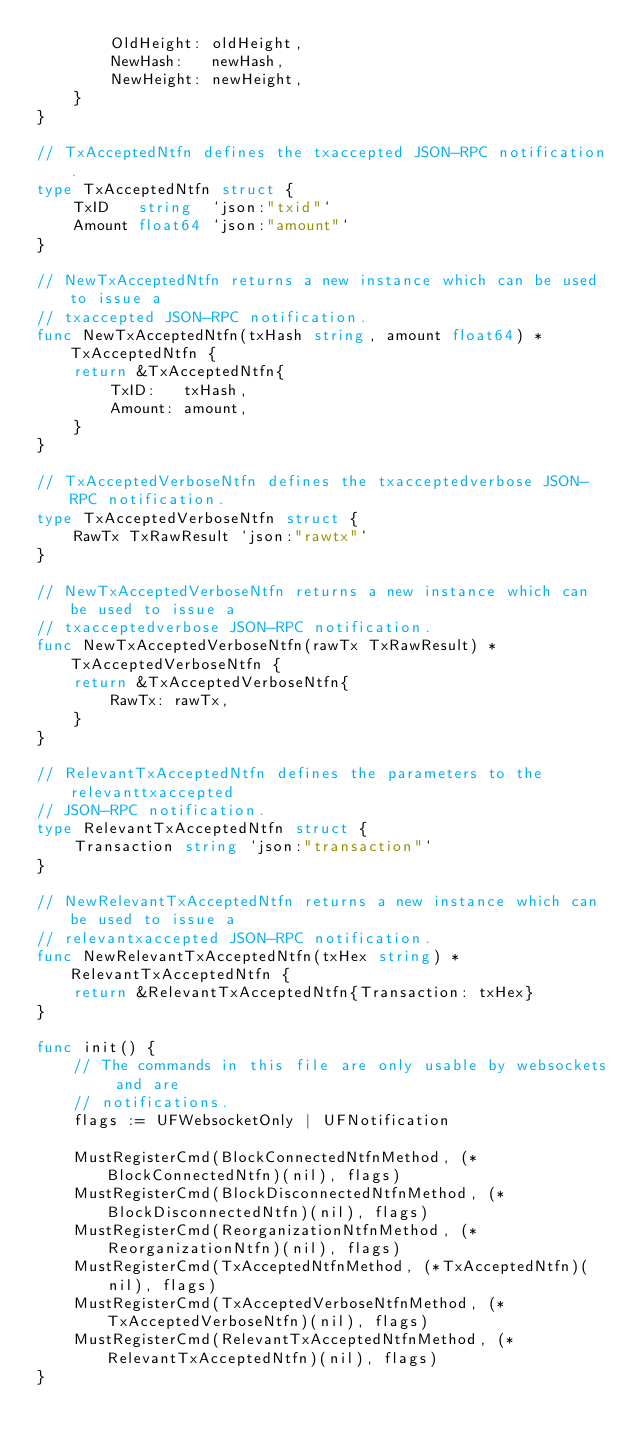<code> <loc_0><loc_0><loc_500><loc_500><_Go_>		OldHeight: oldHeight,
		NewHash:   newHash,
		NewHeight: newHeight,
	}
}

// TxAcceptedNtfn defines the txaccepted JSON-RPC notification.
type TxAcceptedNtfn struct {
	TxID   string  `json:"txid"`
	Amount float64 `json:"amount"`
}

// NewTxAcceptedNtfn returns a new instance which can be used to issue a
// txaccepted JSON-RPC notification.
func NewTxAcceptedNtfn(txHash string, amount float64) *TxAcceptedNtfn {
	return &TxAcceptedNtfn{
		TxID:   txHash,
		Amount: amount,
	}
}

// TxAcceptedVerboseNtfn defines the txacceptedverbose JSON-RPC notification.
type TxAcceptedVerboseNtfn struct {
	RawTx TxRawResult `json:"rawtx"`
}

// NewTxAcceptedVerboseNtfn returns a new instance which can be used to issue a
// txacceptedverbose JSON-RPC notification.
func NewTxAcceptedVerboseNtfn(rawTx TxRawResult) *TxAcceptedVerboseNtfn {
	return &TxAcceptedVerboseNtfn{
		RawTx: rawTx,
	}
}

// RelevantTxAcceptedNtfn defines the parameters to the relevanttxaccepted
// JSON-RPC notification.
type RelevantTxAcceptedNtfn struct {
	Transaction string `json:"transaction"`
}

// NewRelevantTxAcceptedNtfn returns a new instance which can be used to issue a
// relevantxaccepted JSON-RPC notification.
func NewRelevantTxAcceptedNtfn(txHex string) *RelevantTxAcceptedNtfn {
	return &RelevantTxAcceptedNtfn{Transaction: txHex}
}

func init() {
	// The commands in this file are only usable by websockets and are
	// notifications.
	flags := UFWebsocketOnly | UFNotification

	MustRegisterCmd(BlockConnectedNtfnMethod, (*BlockConnectedNtfn)(nil), flags)
	MustRegisterCmd(BlockDisconnectedNtfnMethod, (*BlockDisconnectedNtfn)(nil), flags)
	MustRegisterCmd(ReorganizationNtfnMethod, (*ReorganizationNtfn)(nil), flags)
	MustRegisterCmd(TxAcceptedNtfnMethod, (*TxAcceptedNtfn)(nil), flags)
	MustRegisterCmd(TxAcceptedVerboseNtfnMethod, (*TxAcceptedVerboseNtfn)(nil), flags)
	MustRegisterCmd(RelevantTxAcceptedNtfnMethod, (*RelevantTxAcceptedNtfn)(nil), flags)
}
</code> 